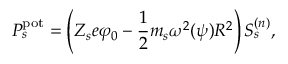Convert formula to latex. <formula><loc_0><loc_0><loc_500><loc_500>P _ { s } ^ { p o t } = \left ( Z _ { s } e \varphi _ { 0 } - \frac { 1 } { 2 } m _ { s } \omega ^ { 2 } ( \psi ) R ^ { 2 } \right ) S _ { s } ^ { ( { n } ) } ,</formula> 